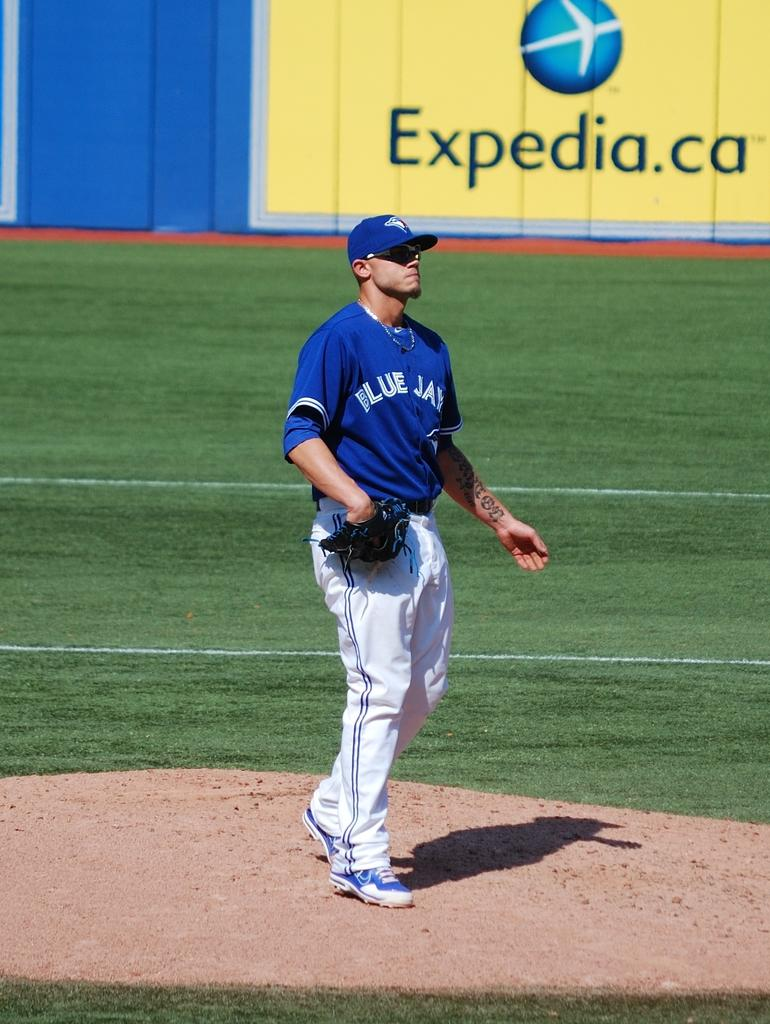<image>
Render a clear and concise summary of the photo. Expedia.ca is sponsoring a blue bay baseball team 